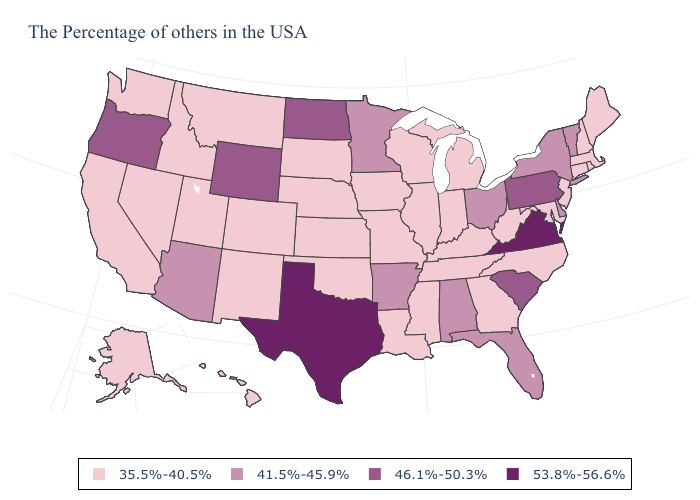Name the states that have a value in the range 53.8%-56.6%?
Give a very brief answer. Virginia, Texas. What is the value of Vermont?
Keep it brief. 41.5%-45.9%. Name the states that have a value in the range 35.5%-40.5%?
Short answer required. Maine, Massachusetts, Rhode Island, New Hampshire, Connecticut, New Jersey, Maryland, North Carolina, West Virginia, Georgia, Michigan, Kentucky, Indiana, Tennessee, Wisconsin, Illinois, Mississippi, Louisiana, Missouri, Iowa, Kansas, Nebraska, Oklahoma, South Dakota, Colorado, New Mexico, Utah, Montana, Idaho, Nevada, California, Washington, Alaska, Hawaii. Does Kansas have a lower value than New Mexico?
Quick response, please. No. Which states have the lowest value in the MidWest?
Keep it brief. Michigan, Indiana, Wisconsin, Illinois, Missouri, Iowa, Kansas, Nebraska, South Dakota. Which states have the lowest value in the USA?
Concise answer only. Maine, Massachusetts, Rhode Island, New Hampshire, Connecticut, New Jersey, Maryland, North Carolina, West Virginia, Georgia, Michigan, Kentucky, Indiana, Tennessee, Wisconsin, Illinois, Mississippi, Louisiana, Missouri, Iowa, Kansas, Nebraska, Oklahoma, South Dakota, Colorado, New Mexico, Utah, Montana, Idaho, Nevada, California, Washington, Alaska, Hawaii. Name the states that have a value in the range 46.1%-50.3%?
Concise answer only. Pennsylvania, South Carolina, North Dakota, Wyoming, Oregon. Name the states that have a value in the range 53.8%-56.6%?
Give a very brief answer. Virginia, Texas. Name the states that have a value in the range 46.1%-50.3%?
Be succinct. Pennsylvania, South Carolina, North Dakota, Wyoming, Oregon. Does the map have missing data?
Answer briefly. No. Name the states that have a value in the range 46.1%-50.3%?
Give a very brief answer. Pennsylvania, South Carolina, North Dakota, Wyoming, Oregon. What is the lowest value in the USA?
Quick response, please. 35.5%-40.5%. Does Arizona have a higher value than Utah?
Quick response, please. Yes. Name the states that have a value in the range 35.5%-40.5%?
Concise answer only. Maine, Massachusetts, Rhode Island, New Hampshire, Connecticut, New Jersey, Maryland, North Carolina, West Virginia, Georgia, Michigan, Kentucky, Indiana, Tennessee, Wisconsin, Illinois, Mississippi, Louisiana, Missouri, Iowa, Kansas, Nebraska, Oklahoma, South Dakota, Colorado, New Mexico, Utah, Montana, Idaho, Nevada, California, Washington, Alaska, Hawaii. 